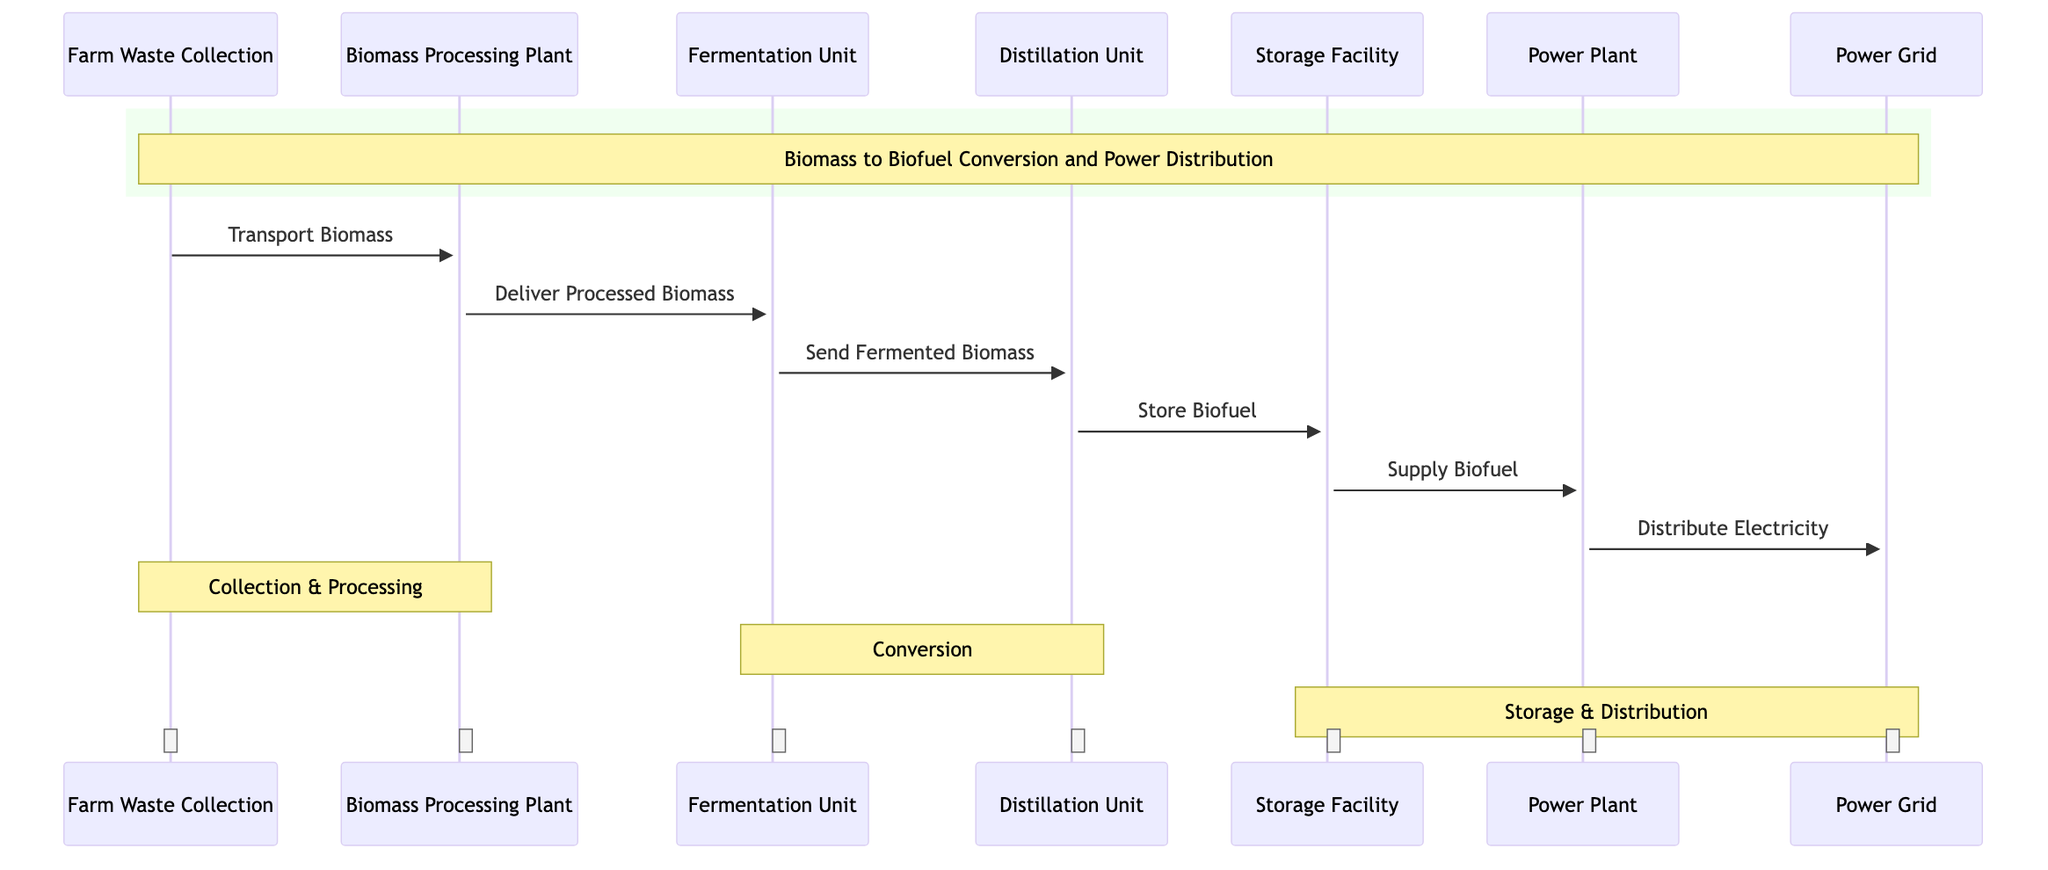What is the first action in the process? The first action is represented by the arrow from "Farm Waste Collection" to "Biomass Processing Plant," indicating the transport of biomass.
Answer: Transport Biomass How many units are involved in the conversion process? The units involved in the conversion process are Biomass Processing Plant, Fermentation Unit, and Distillation Unit, totaling three units.
Answer: Three Which unit receives the biofuel before it is sent to the power plant? The unit that receives the biofuel before it is supplied to the power plant is the Storage Facility, indicated by the arrow from Distillation Unit to Storage Facility.
Answer: Storage Facility What is the last step in the sequence? The last step in the sequence is the distribution of electricity from the Power Plant to the Power Grid, as shown by the final arrow.
Answer: Distribute Electricity How many transport actions are represented in the diagram? There are five distinct transport actions shown in the diagram: Transport Biomass, Deliver Processed Biomass, Send Fermented Biomass, Store Biofuel, and Supply Biofuel.
Answer: Five What is the relationship between the Distillation Unit and Storage Facility? The relationship is that the Distillation Unit sends the fermented biomass to the Storage Facility as indicated by the directional arrow labeled "Send Fermented Biomass."
Answer: Send Fermented Biomass What do the notes represent in the diagram? The notes over the respective groups of units indicate the overall process categories, including Collection & Processing, Conversion, and Storage & Distribution, summarizing the stages of the process.
Answer: Process Categories Which unit is responsible for supplying biofuel to the power plant? The unit responsible for supplying biofuel to the power plant is the Storage Facility, as indicated by the arrow labeled "Supply Biofuel."
Answer: Storage Facility 